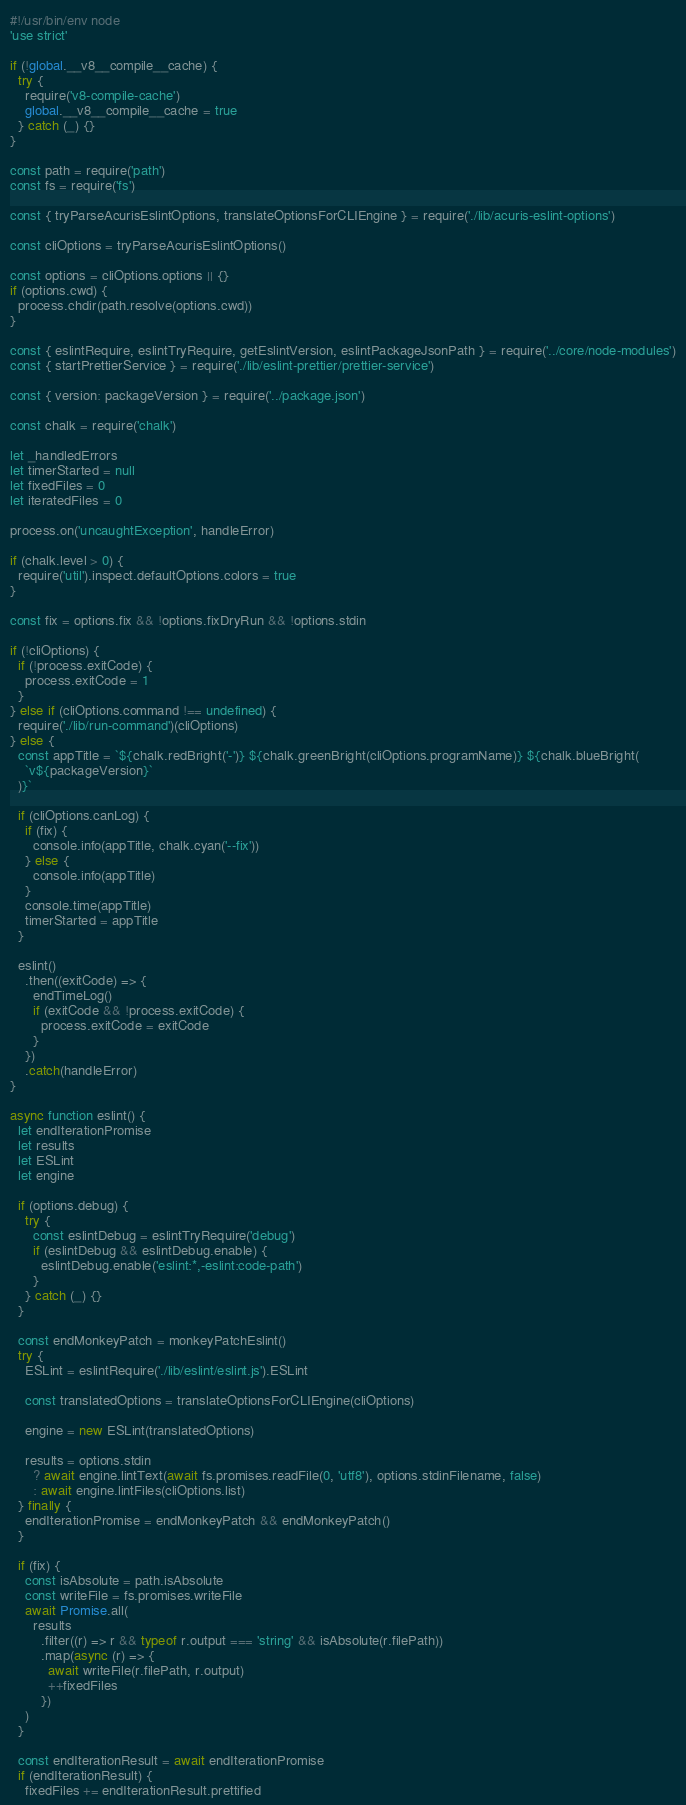<code> <loc_0><loc_0><loc_500><loc_500><_JavaScript_>#!/usr/bin/env node
'use strict'

if (!global.__v8__compile__cache) {
  try {
    require('v8-compile-cache')
    global.__v8__compile__cache = true
  } catch (_) {}
}

const path = require('path')
const fs = require('fs')

const { tryParseAcurisEslintOptions, translateOptionsForCLIEngine } = require('./lib/acuris-eslint-options')

const cliOptions = tryParseAcurisEslintOptions()

const options = cliOptions.options || {}
if (options.cwd) {
  process.chdir(path.resolve(options.cwd))
}

const { eslintRequire, eslintTryRequire, getEslintVersion, eslintPackageJsonPath } = require('../core/node-modules')
const { startPrettierService } = require('./lib/eslint-prettier/prettier-service')

const { version: packageVersion } = require('../package.json')

const chalk = require('chalk')

let _handledErrors
let timerStarted = null
let fixedFiles = 0
let iteratedFiles = 0

process.on('uncaughtException', handleError)

if (chalk.level > 0) {
  require('util').inspect.defaultOptions.colors = true
}

const fix = options.fix && !options.fixDryRun && !options.stdin

if (!cliOptions) {
  if (!process.exitCode) {
    process.exitCode = 1
  }
} else if (cliOptions.command !== undefined) {
  require('./lib/run-command')(cliOptions)
} else {
  const appTitle = `${chalk.redBright('-')} ${chalk.greenBright(cliOptions.programName)} ${chalk.blueBright(
    `v${packageVersion}`
  )}`

  if (cliOptions.canLog) {
    if (fix) {
      console.info(appTitle, chalk.cyan('--fix'))
    } else {
      console.info(appTitle)
    }
    console.time(appTitle)
    timerStarted = appTitle
  }

  eslint()
    .then((exitCode) => {
      endTimeLog()
      if (exitCode && !process.exitCode) {
        process.exitCode = exitCode
      }
    })
    .catch(handleError)
}

async function eslint() {
  let endIterationPromise
  let results
  let ESLint
  let engine

  if (options.debug) {
    try {
      const eslintDebug = eslintTryRequire('debug')
      if (eslintDebug && eslintDebug.enable) {
        eslintDebug.enable('eslint:*,-eslint:code-path')
      }
    } catch (_) {}
  }

  const endMonkeyPatch = monkeyPatchEslint()
  try {
    ESLint = eslintRequire('./lib/eslint/eslint.js').ESLint

    const translatedOptions = translateOptionsForCLIEngine(cliOptions)

    engine = new ESLint(translatedOptions)

    results = options.stdin
      ? await engine.lintText(await fs.promises.readFile(0, 'utf8'), options.stdinFilename, false)
      : await engine.lintFiles(cliOptions.list)
  } finally {
    endIterationPromise = endMonkeyPatch && endMonkeyPatch()
  }

  if (fix) {
    const isAbsolute = path.isAbsolute
    const writeFile = fs.promises.writeFile
    await Promise.all(
      results
        .filter((r) => r && typeof r.output === 'string' && isAbsolute(r.filePath))
        .map(async (r) => {
          await writeFile(r.filePath, r.output)
          ++fixedFiles
        })
    )
  }

  const endIterationResult = await endIterationPromise
  if (endIterationResult) {
    fixedFiles += endIterationResult.prettified</code> 